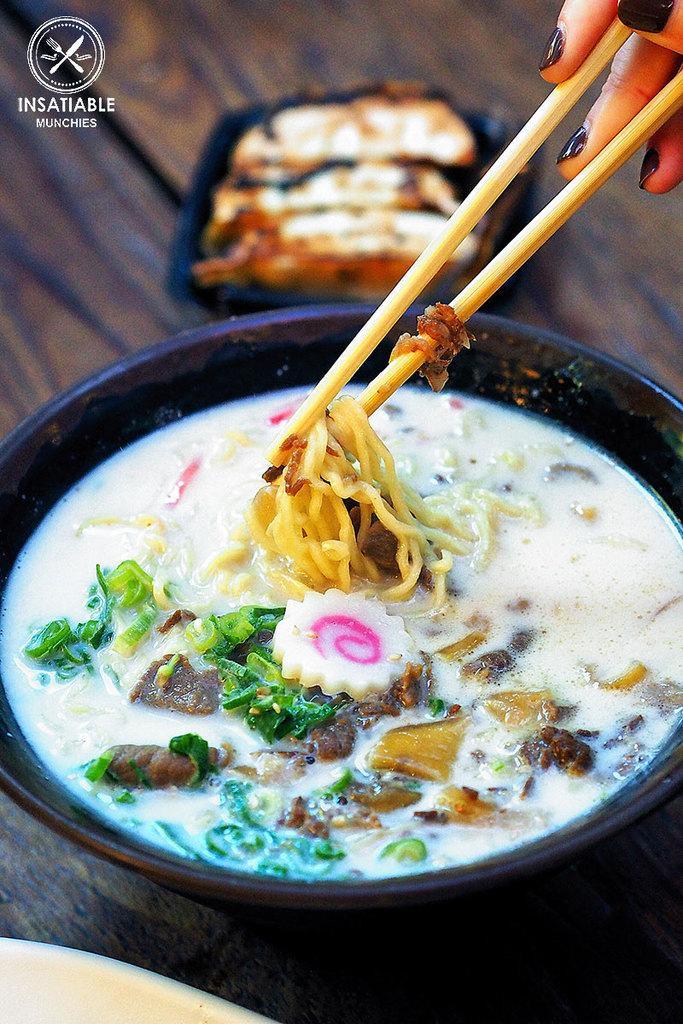Could you give a brief overview of what you see in this image? We can see bowl,food,plate on the table and we can see sticks hold with hands. 